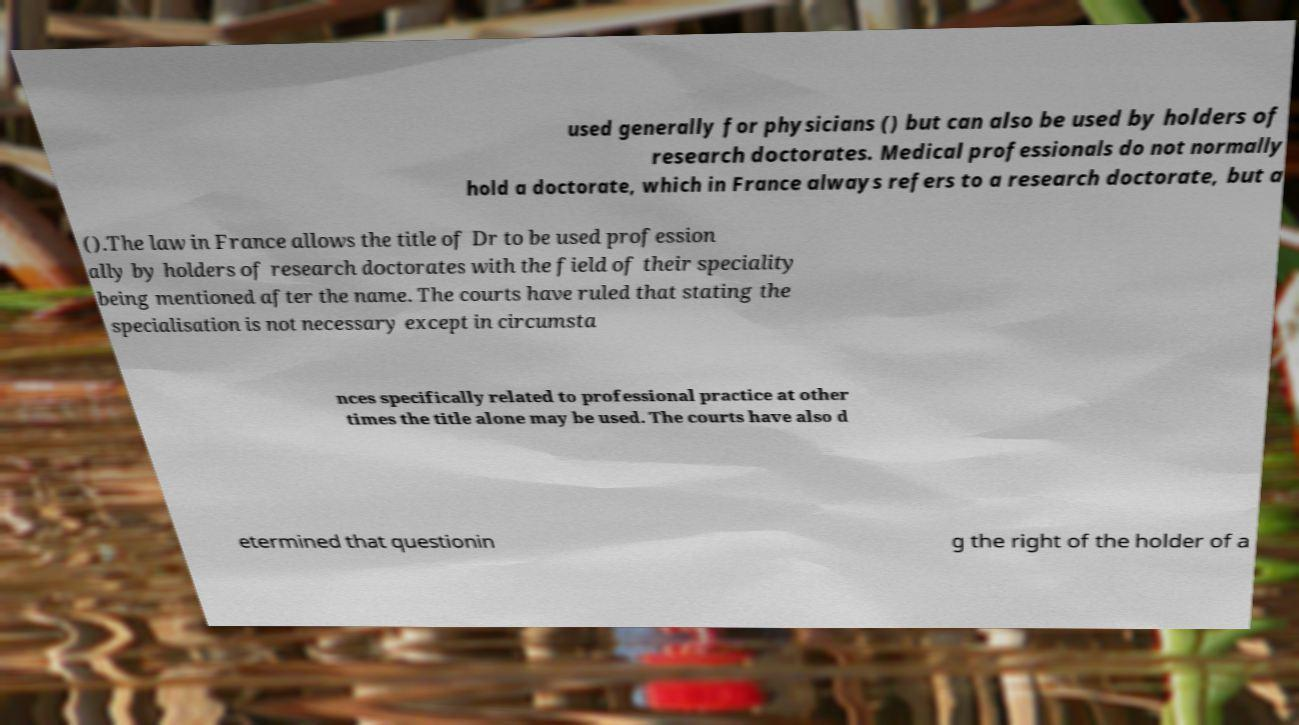Can you read and provide the text displayed in the image?This photo seems to have some interesting text. Can you extract and type it out for me? used generally for physicians () but can also be used by holders of research doctorates. Medical professionals do not normally hold a doctorate, which in France always refers to a research doctorate, but a ().The law in France allows the title of Dr to be used profession ally by holders of research doctorates with the field of their speciality being mentioned after the name. The courts have ruled that stating the specialisation is not necessary except in circumsta nces specifically related to professional practice at other times the title alone may be used. The courts have also d etermined that questionin g the right of the holder of a 